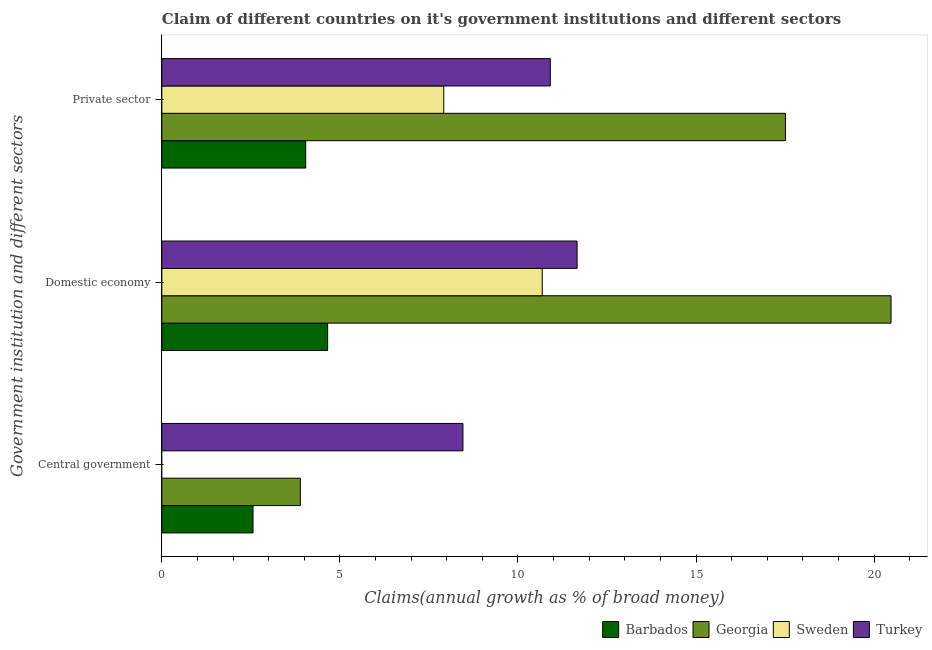How many groups of bars are there?
Provide a succinct answer. 3. How many bars are there on the 3rd tick from the top?
Provide a succinct answer. 3. What is the label of the 2nd group of bars from the top?
Your answer should be compact. Domestic economy. What is the percentage of claim on the central government in Barbados?
Provide a short and direct response. 2.56. Across all countries, what is the maximum percentage of claim on the domestic economy?
Your answer should be compact. 20.47. Across all countries, what is the minimum percentage of claim on the central government?
Your answer should be compact. 0. In which country was the percentage of claim on the domestic economy maximum?
Provide a short and direct response. Georgia. What is the total percentage of claim on the private sector in the graph?
Give a very brief answer. 40.37. What is the difference between the percentage of claim on the domestic economy in Georgia and that in Barbados?
Give a very brief answer. 15.82. What is the difference between the percentage of claim on the private sector in Barbados and the percentage of claim on the central government in Georgia?
Ensure brevity in your answer.  0.15. What is the average percentage of claim on the central government per country?
Your answer should be very brief. 3.73. What is the difference between the percentage of claim on the domestic economy and percentage of claim on the private sector in Georgia?
Your response must be concise. 2.96. In how many countries, is the percentage of claim on the domestic economy greater than 10 %?
Make the answer very short. 3. What is the ratio of the percentage of claim on the private sector in Turkey to that in Sweden?
Ensure brevity in your answer.  1.38. Is the difference between the percentage of claim on the central government in Turkey and Georgia greater than the difference between the percentage of claim on the domestic economy in Turkey and Georgia?
Provide a succinct answer. Yes. What is the difference between the highest and the second highest percentage of claim on the central government?
Keep it short and to the point. 4.57. What is the difference between the highest and the lowest percentage of claim on the private sector?
Make the answer very short. 13.47. In how many countries, is the percentage of claim on the central government greater than the average percentage of claim on the central government taken over all countries?
Keep it short and to the point. 2. Are all the bars in the graph horizontal?
Make the answer very short. Yes. How many countries are there in the graph?
Give a very brief answer. 4. Are the values on the major ticks of X-axis written in scientific E-notation?
Your answer should be very brief. No. Does the graph contain any zero values?
Your response must be concise. Yes. How many legend labels are there?
Provide a succinct answer. 4. What is the title of the graph?
Your answer should be very brief. Claim of different countries on it's government institutions and different sectors. Does "Somalia" appear as one of the legend labels in the graph?
Offer a very short reply. No. What is the label or title of the X-axis?
Offer a terse response. Claims(annual growth as % of broad money). What is the label or title of the Y-axis?
Ensure brevity in your answer.  Government institution and different sectors. What is the Claims(annual growth as % of broad money) of Barbados in Central government?
Offer a very short reply. 2.56. What is the Claims(annual growth as % of broad money) of Georgia in Central government?
Offer a terse response. 3.89. What is the Claims(annual growth as % of broad money) of Sweden in Central government?
Keep it short and to the point. 0. What is the Claims(annual growth as % of broad money) in Turkey in Central government?
Provide a succinct answer. 8.45. What is the Claims(annual growth as % of broad money) in Barbados in Domestic economy?
Keep it short and to the point. 4.66. What is the Claims(annual growth as % of broad money) of Georgia in Domestic economy?
Offer a terse response. 20.47. What is the Claims(annual growth as % of broad money) of Sweden in Domestic economy?
Provide a short and direct response. 10.68. What is the Claims(annual growth as % of broad money) of Turkey in Domestic economy?
Your answer should be compact. 11.66. What is the Claims(annual growth as % of broad money) in Barbados in Private sector?
Offer a terse response. 4.04. What is the Claims(annual growth as % of broad money) of Georgia in Private sector?
Your answer should be very brief. 17.51. What is the Claims(annual growth as % of broad money) of Sweden in Private sector?
Offer a very short reply. 7.92. What is the Claims(annual growth as % of broad money) in Turkey in Private sector?
Give a very brief answer. 10.91. Across all Government institution and different sectors, what is the maximum Claims(annual growth as % of broad money) in Barbados?
Make the answer very short. 4.66. Across all Government institution and different sectors, what is the maximum Claims(annual growth as % of broad money) of Georgia?
Offer a very short reply. 20.47. Across all Government institution and different sectors, what is the maximum Claims(annual growth as % of broad money) in Sweden?
Offer a very short reply. 10.68. Across all Government institution and different sectors, what is the maximum Claims(annual growth as % of broad money) of Turkey?
Keep it short and to the point. 11.66. Across all Government institution and different sectors, what is the minimum Claims(annual growth as % of broad money) in Barbados?
Ensure brevity in your answer.  2.56. Across all Government institution and different sectors, what is the minimum Claims(annual growth as % of broad money) of Georgia?
Your response must be concise. 3.89. Across all Government institution and different sectors, what is the minimum Claims(annual growth as % of broad money) of Sweden?
Your answer should be compact. 0. Across all Government institution and different sectors, what is the minimum Claims(annual growth as % of broad money) in Turkey?
Offer a very short reply. 8.45. What is the total Claims(annual growth as % of broad money) in Barbados in the graph?
Keep it short and to the point. 11.26. What is the total Claims(annual growth as % of broad money) in Georgia in the graph?
Offer a terse response. 41.87. What is the total Claims(annual growth as % of broad money) in Sweden in the graph?
Your response must be concise. 18.6. What is the total Claims(annual growth as % of broad money) of Turkey in the graph?
Your answer should be very brief. 31.02. What is the difference between the Claims(annual growth as % of broad money) of Barbados in Central government and that in Domestic economy?
Ensure brevity in your answer.  -2.1. What is the difference between the Claims(annual growth as % of broad money) of Georgia in Central government and that in Domestic economy?
Provide a succinct answer. -16.59. What is the difference between the Claims(annual growth as % of broad money) in Turkey in Central government and that in Domestic economy?
Provide a short and direct response. -3.2. What is the difference between the Claims(annual growth as % of broad money) of Barbados in Central government and that in Private sector?
Make the answer very short. -1.48. What is the difference between the Claims(annual growth as % of broad money) in Georgia in Central government and that in Private sector?
Make the answer very short. -13.62. What is the difference between the Claims(annual growth as % of broad money) of Turkey in Central government and that in Private sector?
Offer a terse response. -2.45. What is the difference between the Claims(annual growth as % of broad money) in Barbados in Domestic economy and that in Private sector?
Keep it short and to the point. 0.62. What is the difference between the Claims(annual growth as % of broad money) in Georgia in Domestic economy and that in Private sector?
Provide a succinct answer. 2.96. What is the difference between the Claims(annual growth as % of broad money) in Sweden in Domestic economy and that in Private sector?
Give a very brief answer. 2.76. What is the difference between the Claims(annual growth as % of broad money) in Turkey in Domestic economy and that in Private sector?
Your response must be concise. 0.75. What is the difference between the Claims(annual growth as % of broad money) of Barbados in Central government and the Claims(annual growth as % of broad money) of Georgia in Domestic economy?
Offer a terse response. -17.91. What is the difference between the Claims(annual growth as % of broad money) of Barbados in Central government and the Claims(annual growth as % of broad money) of Sweden in Domestic economy?
Offer a terse response. -8.12. What is the difference between the Claims(annual growth as % of broad money) in Barbados in Central government and the Claims(annual growth as % of broad money) in Turkey in Domestic economy?
Ensure brevity in your answer.  -9.1. What is the difference between the Claims(annual growth as % of broad money) in Georgia in Central government and the Claims(annual growth as % of broad money) in Sweden in Domestic economy?
Give a very brief answer. -6.79. What is the difference between the Claims(annual growth as % of broad money) in Georgia in Central government and the Claims(annual growth as % of broad money) in Turkey in Domestic economy?
Offer a very short reply. -7.77. What is the difference between the Claims(annual growth as % of broad money) in Barbados in Central government and the Claims(annual growth as % of broad money) in Georgia in Private sector?
Offer a very short reply. -14.95. What is the difference between the Claims(annual growth as % of broad money) of Barbados in Central government and the Claims(annual growth as % of broad money) of Sweden in Private sector?
Keep it short and to the point. -5.36. What is the difference between the Claims(annual growth as % of broad money) in Barbados in Central government and the Claims(annual growth as % of broad money) in Turkey in Private sector?
Give a very brief answer. -8.35. What is the difference between the Claims(annual growth as % of broad money) in Georgia in Central government and the Claims(annual growth as % of broad money) in Sweden in Private sector?
Give a very brief answer. -4.03. What is the difference between the Claims(annual growth as % of broad money) in Georgia in Central government and the Claims(annual growth as % of broad money) in Turkey in Private sector?
Keep it short and to the point. -7.02. What is the difference between the Claims(annual growth as % of broad money) of Barbados in Domestic economy and the Claims(annual growth as % of broad money) of Georgia in Private sector?
Make the answer very short. -12.85. What is the difference between the Claims(annual growth as % of broad money) in Barbados in Domestic economy and the Claims(annual growth as % of broad money) in Sweden in Private sector?
Offer a very short reply. -3.26. What is the difference between the Claims(annual growth as % of broad money) in Barbados in Domestic economy and the Claims(annual growth as % of broad money) in Turkey in Private sector?
Give a very brief answer. -6.25. What is the difference between the Claims(annual growth as % of broad money) of Georgia in Domestic economy and the Claims(annual growth as % of broad money) of Sweden in Private sector?
Ensure brevity in your answer.  12.56. What is the difference between the Claims(annual growth as % of broad money) in Georgia in Domestic economy and the Claims(annual growth as % of broad money) in Turkey in Private sector?
Your answer should be very brief. 9.57. What is the difference between the Claims(annual growth as % of broad money) of Sweden in Domestic economy and the Claims(annual growth as % of broad money) of Turkey in Private sector?
Ensure brevity in your answer.  -0.23. What is the average Claims(annual growth as % of broad money) in Barbados per Government institution and different sectors?
Your response must be concise. 3.75. What is the average Claims(annual growth as % of broad money) in Georgia per Government institution and different sectors?
Offer a terse response. 13.96. What is the average Claims(annual growth as % of broad money) of Sweden per Government institution and different sectors?
Provide a short and direct response. 6.2. What is the average Claims(annual growth as % of broad money) in Turkey per Government institution and different sectors?
Your answer should be very brief. 10.34. What is the difference between the Claims(annual growth as % of broad money) in Barbados and Claims(annual growth as % of broad money) in Georgia in Central government?
Ensure brevity in your answer.  -1.33. What is the difference between the Claims(annual growth as % of broad money) of Barbados and Claims(annual growth as % of broad money) of Turkey in Central government?
Your response must be concise. -5.89. What is the difference between the Claims(annual growth as % of broad money) of Georgia and Claims(annual growth as % of broad money) of Turkey in Central government?
Offer a very short reply. -4.57. What is the difference between the Claims(annual growth as % of broad money) of Barbados and Claims(annual growth as % of broad money) of Georgia in Domestic economy?
Ensure brevity in your answer.  -15.82. What is the difference between the Claims(annual growth as % of broad money) of Barbados and Claims(annual growth as % of broad money) of Sweden in Domestic economy?
Ensure brevity in your answer.  -6.03. What is the difference between the Claims(annual growth as % of broad money) of Barbados and Claims(annual growth as % of broad money) of Turkey in Domestic economy?
Provide a short and direct response. -7. What is the difference between the Claims(annual growth as % of broad money) of Georgia and Claims(annual growth as % of broad money) of Sweden in Domestic economy?
Give a very brief answer. 9.79. What is the difference between the Claims(annual growth as % of broad money) in Georgia and Claims(annual growth as % of broad money) in Turkey in Domestic economy?
Provide a short and direct response. 8.81. What is the difference between the Claims(annual growth as % of broad money) in Sweden and Claims(annual growth as % of broad money) in Turkey in Domestic economy?
Make the answer very short. -0.98. What is the difference between the Claims(annual growth as % of broad money) of Barbados and Claims(annual growth as % of broad money) of Georgia in Private sector?
Offer a very short reply. -13.47. What is the difference between the Claims(annual growth as % of broad money) in Barbados and Claims(annual growth as % of broad money) in Sweden in Private sector?
Provide a short and direct response. -3.88. What is the difference between the Claims(annual growth as % of broad money) in Barbados and Claims(annual growth as % of broad money) in Turkey in Private sector?
Ensure brevity in your answer.  -6.87. What is the difference between the Claims(annual growth as % of broad money) in Georgia and Claims(annual growth as % of broad money) in Sweden in Private sector?
Ensure brevity in your answer.  9.59. What is the difference between the Claims(annual growth as % of broad money) in Georgia and Claims(annual growth as % of broad money) in Turkey in Private sector?
Provide a succinct answer. 6.6. What is the difference between the Claims(annual growth as % of broad money) of Sweden and Claims(annual growth as % of broad money) of Turkey in Private sector?
Your response must be concise. -2.99. What is the ratio of the Claims(annual growth as % of broad money) of Barbados in Central government to that in Domestic economy?
Your answer should be very brief. 0.55. What is the ratio of the Claims(annual growth as % of broad money) of Georgia in Central government to that in Domestic economy?
Ensure brevity in your answer.  0.19. What is the ratio of the Claims(annual growth as % of broad money) in Turkey in Central government to that in Domestic economy?
Give a very brief answer. 0.73. What is the ratio of the Claims(annual growth as % of broad money) in Barbados in Central government to that in Private sector?
Offer a very short reply. 0.63. What is the ratio of the Claims(annual growth as % of broad money) in Georgia in Central government to that in Private sector?
Ensure brevity in your answer.  0.22. What is the ratio of the Claims(annual growth as % of broad money) of Turkey in Central government to that in Private sector?
Your answer should be very brief. 0.78. What is the ratio of the Claims(annual growth as % of broad money) of Barbados in Domestic economy to that in Private sector?
Give a very brief answer. 1.15. What is the ratio of the Claims(annual growth as % of broad money) of Georgia in Domestic economy to that in Private sector?
Provide a short and direct response. 1.17. What is the ratio of the Claims(annual growth as % of broad money) of Sweden in Domestic economy to that in Private sector?
Give a very brief answer. 1.35. What is the ratio of the Claims(annual growth as % of broad money) in Turkey in Domestic economy to that in Private sector?
Offer a very short reply. 1.07. What is the difference between the highest and the second highest Claims(annual growth as % of broad money) of Barbados?
Your response must be concise. 0.62. What is the difference between the highest and the second highest Claims(annual growth as % of broad money) of Georgia?
Make the answer very short. 2.96. What is the difference between the highest and the second highest Claims(annual growth as % of broad money) of Turkey?
Offer a very short reply. 0.75. What is the difference between the highest and the lowest Claims(annual growth as % of broad money) in Barbados?
Keep it short and to the point. 2.1. What is the difference between the highest and the lowest Claims(annual growth as % of broad money) in Georgia?
Your answer should be compact. 16.59. What is the difference between the highest and the lowest Claims(annual growth as % of broad money) in Sweden?
Your answer should be very brief. 10.68. What is the difference between the highest and the lowest Claims(annual growth as % of broad money) in Turkey?
Make the answer very short. 3.2. 